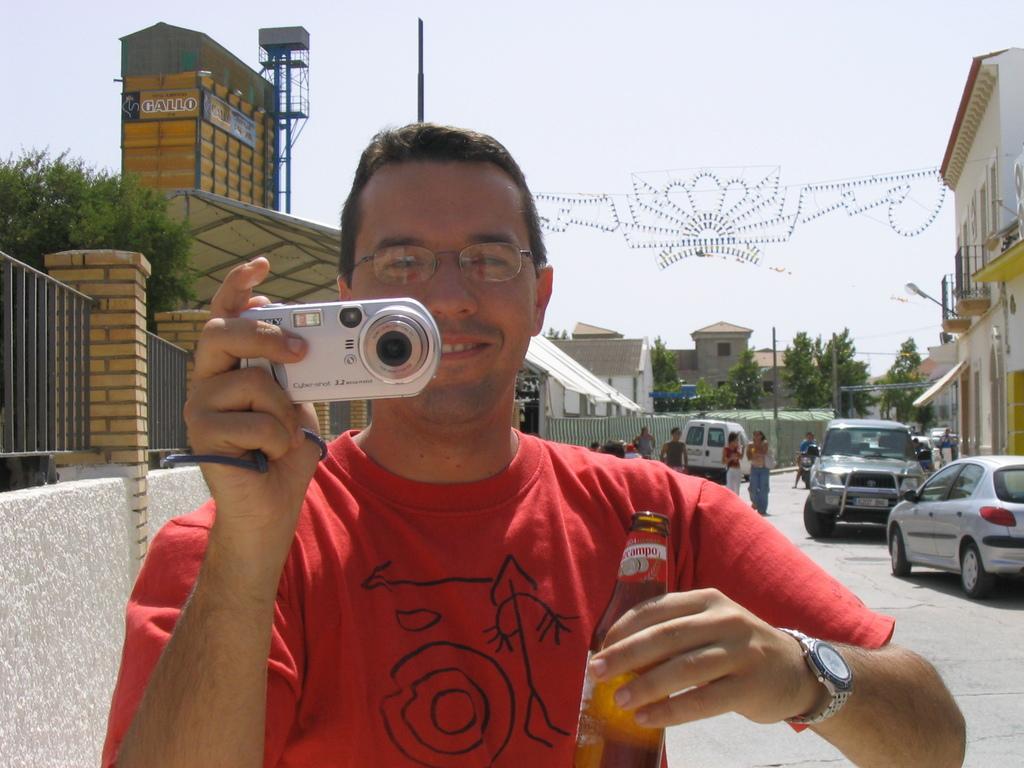Can you describe this image briefly? In this picture we can see a man holding a camera with one hand and bottle with another hand. He wear a watch and he has spectacles. And he is smiling. And here we can see some vehicles on the road. These are the buildings, there are some trees. This is the pole and there is a sky in the background. 